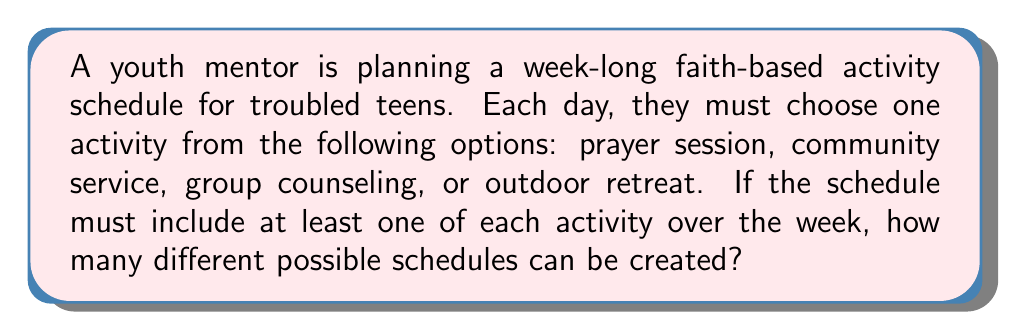What is the answer to this math problem? Let's approach this step-by-step:

1) We have 7 days and 4 types of activities.

2) We must include at least one of each activity, so let's start by assigning one day to each:
   - 1 day for prayer session
   - 1 day for community service
   - 1 day for group counseling
   - 1 day for outdoor retreat

3) This leaves us with 3 days to fill with any of the 4 activities.

4) This scenario can be modeled using the Stars and Bars method in combinatorics. We have 3 identical objects (the remaining days) to distribute among 4 distinct boxes (the activities).

5) The formula for this is:

   $${n+k-1 \choose k-1}$$

   Where $n$ is the number of identical objects and $k$ is the number of distinct boxes.

6) In our case, $n = 3$ and $k = 4$. So we have:

   $${3+4-1 \choose 4-1} = {6 \choose 3}$$

7) We can calculate this:

   $${6 \choose 3} = \frac{6!}{3!(6-3)!} = \frac{6 \cdot 5 \cdot 4}{3 \cdot 2 \cdot 1} = 20$$

Therefore, there are 20 different ways to schedule the remaining 3 days.

8) However, this only accounts for the distribution of the remaining days. We also need to consider the order of all 7 days.

9) For the total number of schedules, we multiply our result by the number of ways to arrange 7 days, which is 7!

10) The final calculation is:

    $$20 \cdot 7! = 20 \cdot 5040 = 100,800$$
Answer: 100,800 